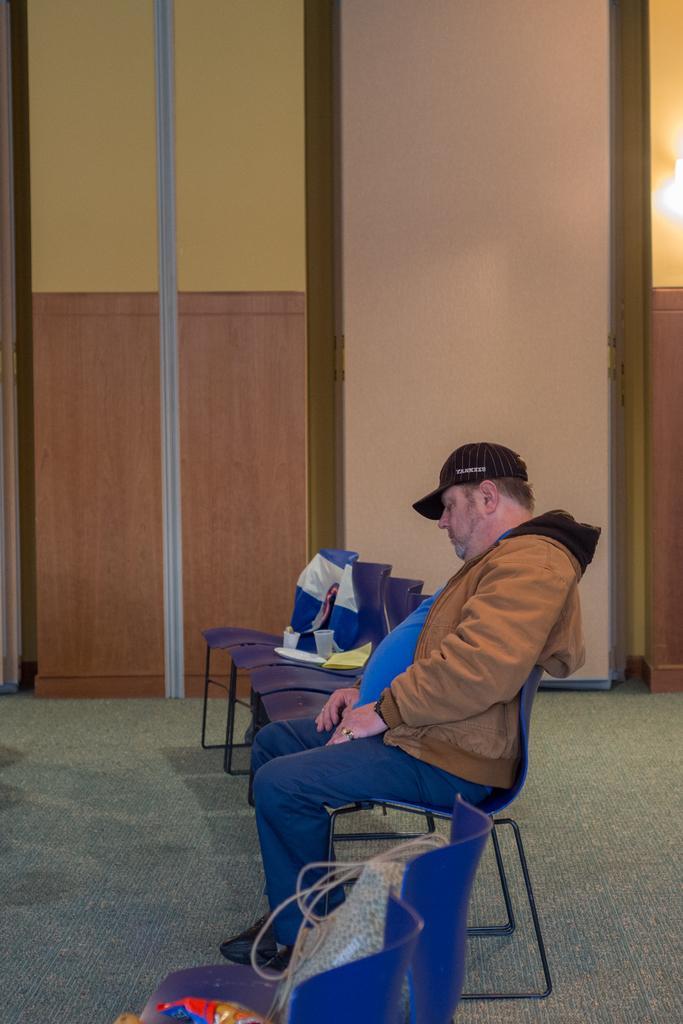Can you describe this image briefly? In the middle bottom a person is sitting on the chair who is wearing a black color cap and brown color jacket. The background wall is of light cream and yellow in color and window is visible on the right. This image is taken inside a wall during day time. 